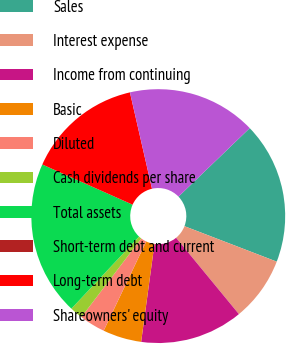<chart> <loc_0><loc_0><loc_500><loc_500><pie_chart><fcel>Sales<fcel>Interest expense<fcel>Income from continuing<fcel>Basic<fcel>Diluted<fcel>Cash dividends per share<fcel>Total assets<fcel>Short-term debt and current<fcel>Long-term debt<fcel>Shareowners' equity<nl><fcel>18.03%<fcel>8.2%<fcel>13.11%<fcel>4.92%<fcel>3.28%<fcel>1.64%<fcel>19.67%<fcel>0.0%<fcel>14.75%<fcel>16.39%<nl></chart> 